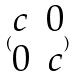<formula> <loc_0><loc_0><loc_500><loc_500>( \begin{matrix} c & 0 \\ 0 & c \end{matrix} )</formula> 